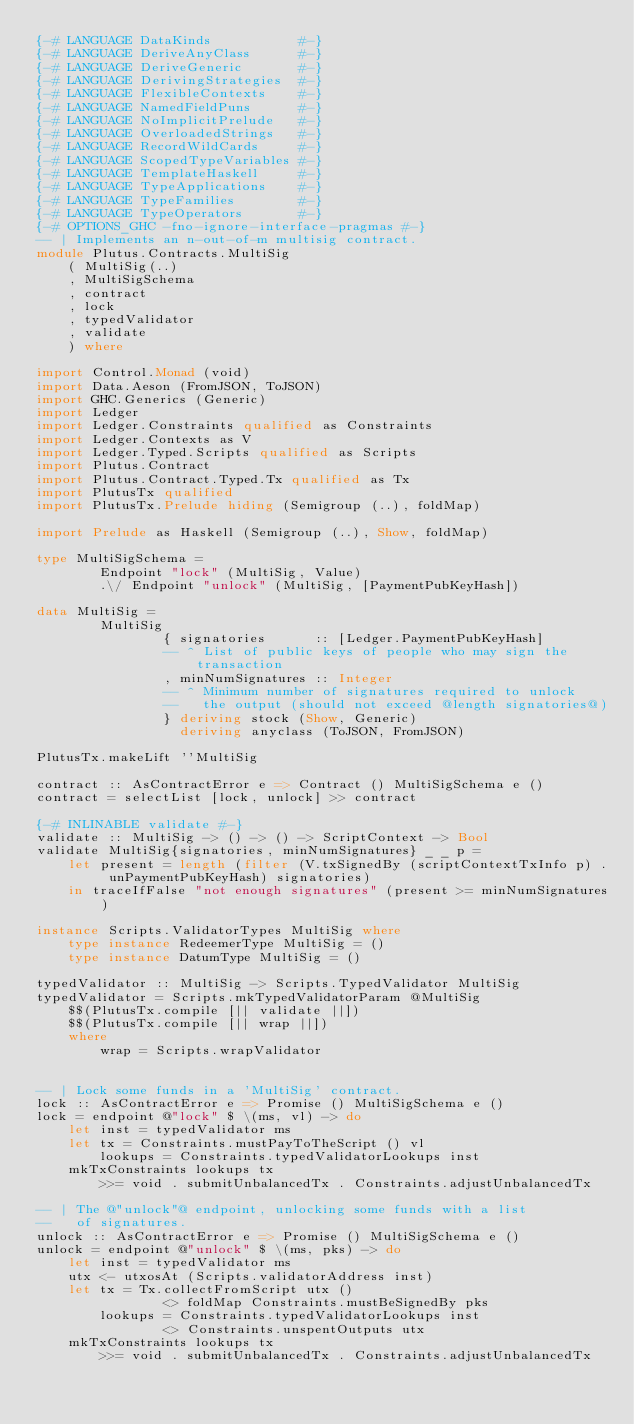Convert code to text. <code><loc_0><loc_0><loc_500><loc_500><_Haskell_>{-# LANGUAGE DataKinds           #-}
{-# LANGUAGE DeriveAnyClass      #-}
{-# LANGUAGE DeriveGeneric       #-}
{-# LANGUAGE DerivingStrategies  #-}
{-# LANGUAGE FlexibleContexts    #-}
{-# LANGUAGE NamedFieldPuns      #-}
{-# LANGUAGE NoImplicitPrelude   #-}
{-# LANGUAGE OverloadedStrings   #-}
{-# LANGUAGE RecordWildCards     #-}
{-# LANGUAGE ScopedTypeVariables #-}
{-# LANGUAGE TemplateHaskell     #-}
{-# LANGUAGE TypeApplications    #-}
{-# LANGUAGE TypeFamilies        #-}
{-# LANGUAGE TypeOperators       #-}
{-# OPTIONS_GHC -fno-ignore-interface-pragmas #-}
-- | Implements an n-out-of-m multisig contract.
module Plutus.Contracts.MultiSig
    ( MultiSig(..)
    , MultiSigSchema
    , contract
    , lock
    , typedValidator
    , validate
    ) where

import Control.Monad (void)
import Data.Aeson (FromJSON, ToJSON)
import GHC.Generics (Generic)
import Ledger
import Ledger.Constraints qualified as Constraints
import Ledger.Contexts as V
import Ledger.Typed.Scripts qualified as Scripts
import Plutus.Contract
import Plutus.Contract.Typed.Tx qualified as Tx
import PlutusTx qualified
import PlutusTx.Prelude hiding (Semigroup (..), foldMap)

import Prelude as Haskell (Semigroup (..), Show, foldMap)

type MultiSigSchema =
        Endpoint "lock" (MultiSig, Value)
        .\/ Endpoint "unlock" (MultiSig, [PaymentPubKeyHash])

data MultiSig =
        MultiSig
                { signatories      :: [Ledger.PaymentPubKeyHash]
                -- ^ List of public keys of people who may sign the transaction
                , minNumSignatures :: Integer
                -- ^ Minimum number of signatures required to unlock
                --   the output (should not exceed @length signatories@)
                } deriving stock (Show, Generic)
                  deriving anyclass (ToJSON, FromJSON)

PlutusTx.makeLift ''MultiSig

contract :: AsContractError e => Contract () MultiSigSchema e ()
contract = selectList [lock, unlock] >> contract

{-# INLINABLE validate #-}
validate :: MultiSig -> () -> () -> ScriptContext -> Bool
validate MultiSig{signatories, minNumSignatures} _ _ p =
    let present = length (filter (V.txSignedBy (scriptContextTxInfo p) . unPaymentPubKeyHash) signatories)
    in traceIfFalse "not enough signatures" (present >= minNumSignatures)

instance Scripts.ValidatorTypes MultiSig where
    type instance RedeemerType MultiSig = ()
    type instance DatumType MultiSig = ()

typedValidator :: MultiSig -> Scripts.TypedValidator MultiSig
typedValidator = Scripts.mkTypedValidatorParam @MultiSig
    $$(PlutusTx.compile [|| validate ||])
    $$(PlutusTx.compile [|| wrap ||])
    where
        wrap = Scripts.wrapValidator


-- | Lock some funds in a 'MultiSig' contract.
lock :: AsContractError e => Promise () MultiSigSchema e ()
lock = endpoint @"lock" $ \(ms, vl) -> do
    let inst = typedValidator ms
    let tx = Constraints.mustPayToTheScript () vl
        lookups = Constraints.typedValidatorLookups inst
    mkTxConstraints lookups tx
        >>= void . submitUnbalancedTx . Constraints.adjustUnbalancedTx

-- | The @"unlock"@ endpoint, unlocking some funds with a list
--   of signatures.
unlock :: AsContractError e => Promise () MultiSigSchema e ()
unlock = endpoint @"unlock" $ \(ms, pks) -> do
    let inst = typedValidator ms
    utx <- utxosAt (Scripts.validatorAddress inst)
    let tx = Tx.collectFromScript utx ()
                <> foldMap Constraints.mustBeSignedBy pks
        lookups = Constraints.typedValidatorLookups inst
                <> Constraints.unspentOutputs utx
    mkTxConstraints lookups tx
        >>= void . submitUnbalancedTx . Constraints.adjustUnbalancedTx
</code> 